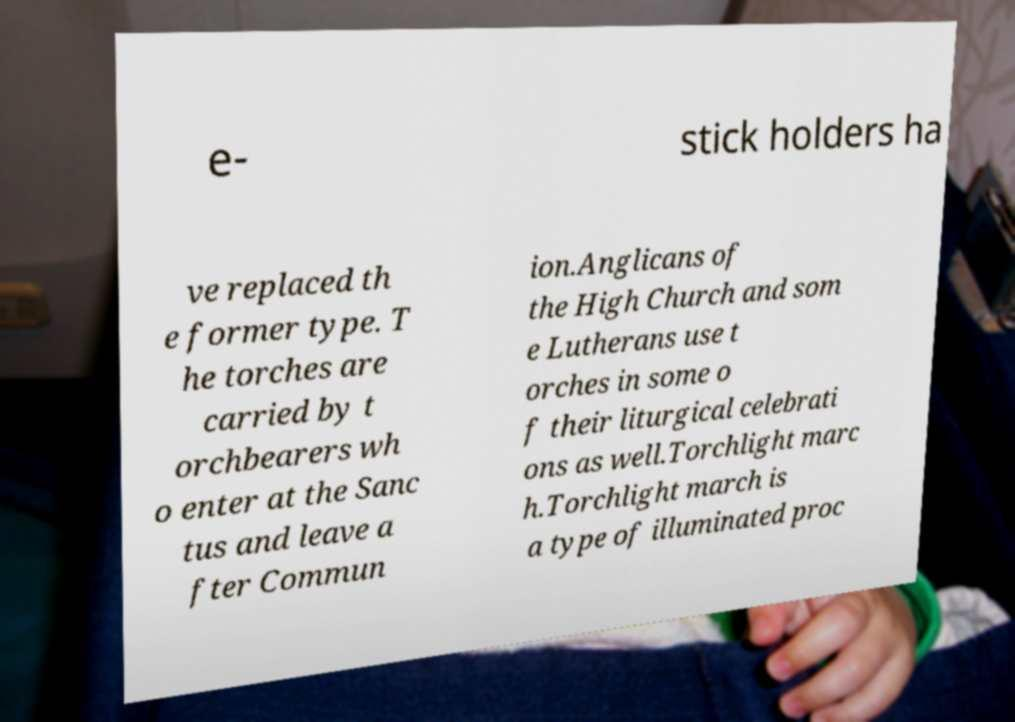For documentation purposes, I need the text within this image transcribed. Could you provide that? e- stick holders ha ve replaced th e former type. T he torches are carried by t orchbearers wh o enter at the Sanc tus and leave a fter Commun ion.Anglicans of the High Church and som e Lutherans use t orches in some o f their liturgical celebrati ons as well.Torchlight marc h.Torchlight march is a type of illuminated proc 